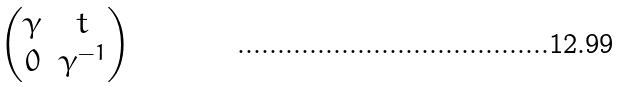<formula> <loc_0><loc_0><loc_500><loc_500>\begin{pmatrix} \gamma & t \\ 0 & \gamma ^ { - 1 } \end{pmatrix}</formula> 